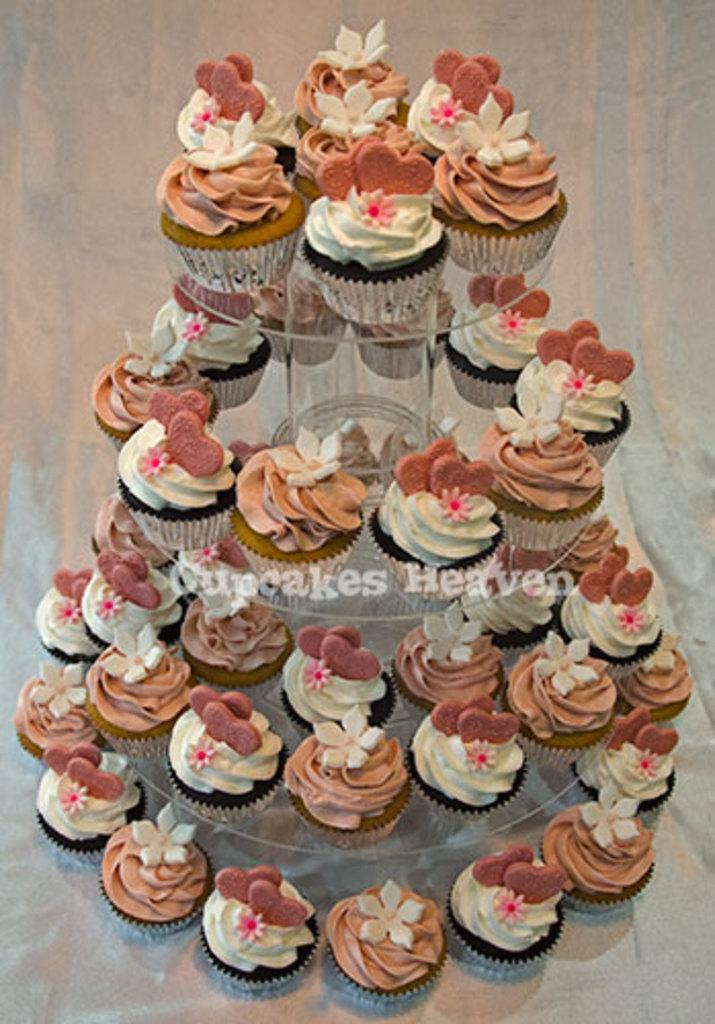What type of dessert can be seen in the image? There are colorful cupcakes in the image. How are the cupcakes arranged or displayed? The cupcakes are on a cake stand. What colors are predominant in the background of the image? The background of the image is cream and white color. What grade does the coach give to the performance in the image? There is no performance or coach present in the image; it features colorful cupcakes on a cake stand with a cream and white background. 